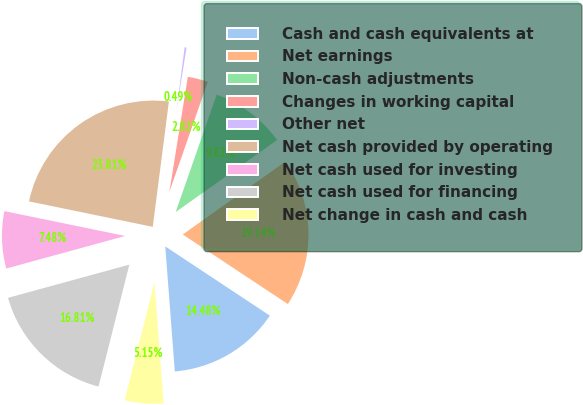<chart> <loc_0><loc_0><loc_500><loc_500><pie_chart><fcel>Cash and cash equivalents at<fcel>Net earnings<fcel>Non-cash adjustments<fcel>Changes in working capital<fcel>Other net<fcel>Net cash provided by operating<fcel>Net cash used for investing<fcel>Net cash used for financing<fcel>Net change in cash and cash<nl><fcel>14.48%<fcel>19.14%<fcel>9.82%<fcel>2.82%<fcel>0.49%<fcel>23.81%<fcel>7.48%<fcel>16.81%<fcel>5.15%<nl></chart> 